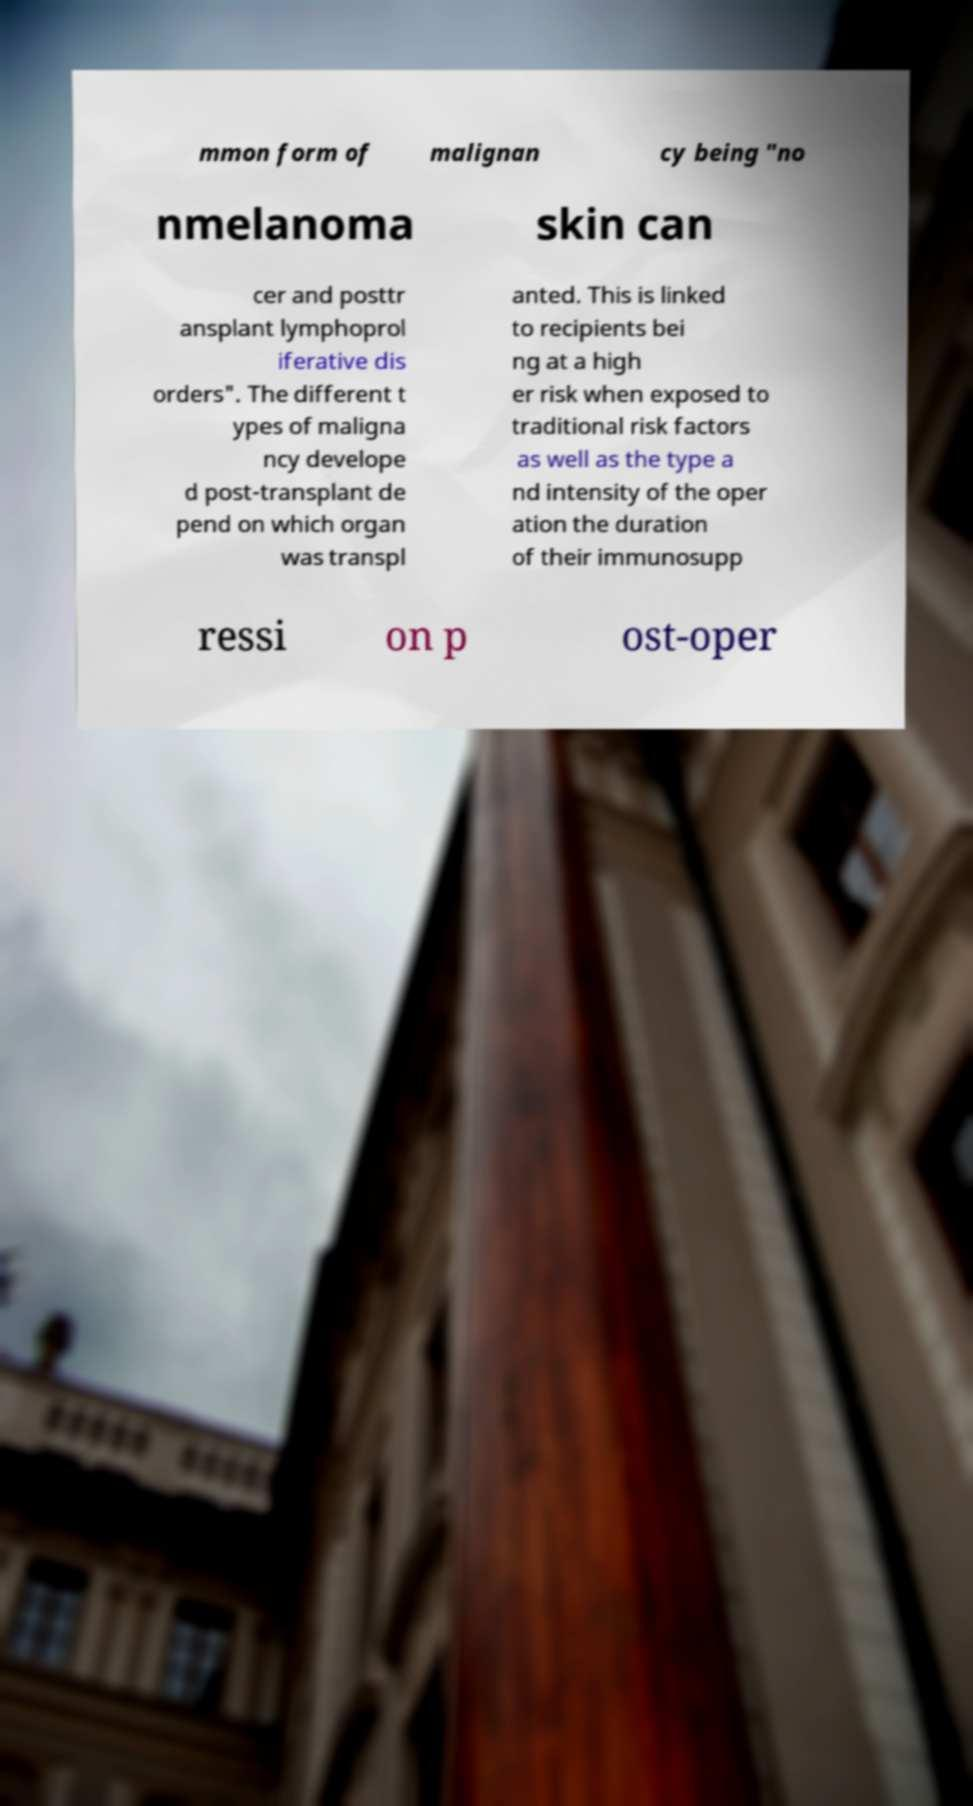There's text embedded in this image that I need extracted. Can you transcribe it verbatim? mmon form of malignan cy being "no nmelanoma skin can cer and posttr ansplant lymphoprol iferative dis orders". The different t ypes of maligna ncy develope d post-transplant de pend on which organ was transpl anted. This is linked to recipients bei ng at a high er risk when exposed to traditional risk factors as well as the type a nd intensity of the oper ation the duration of their immunosupp ressi on p ost-oper 